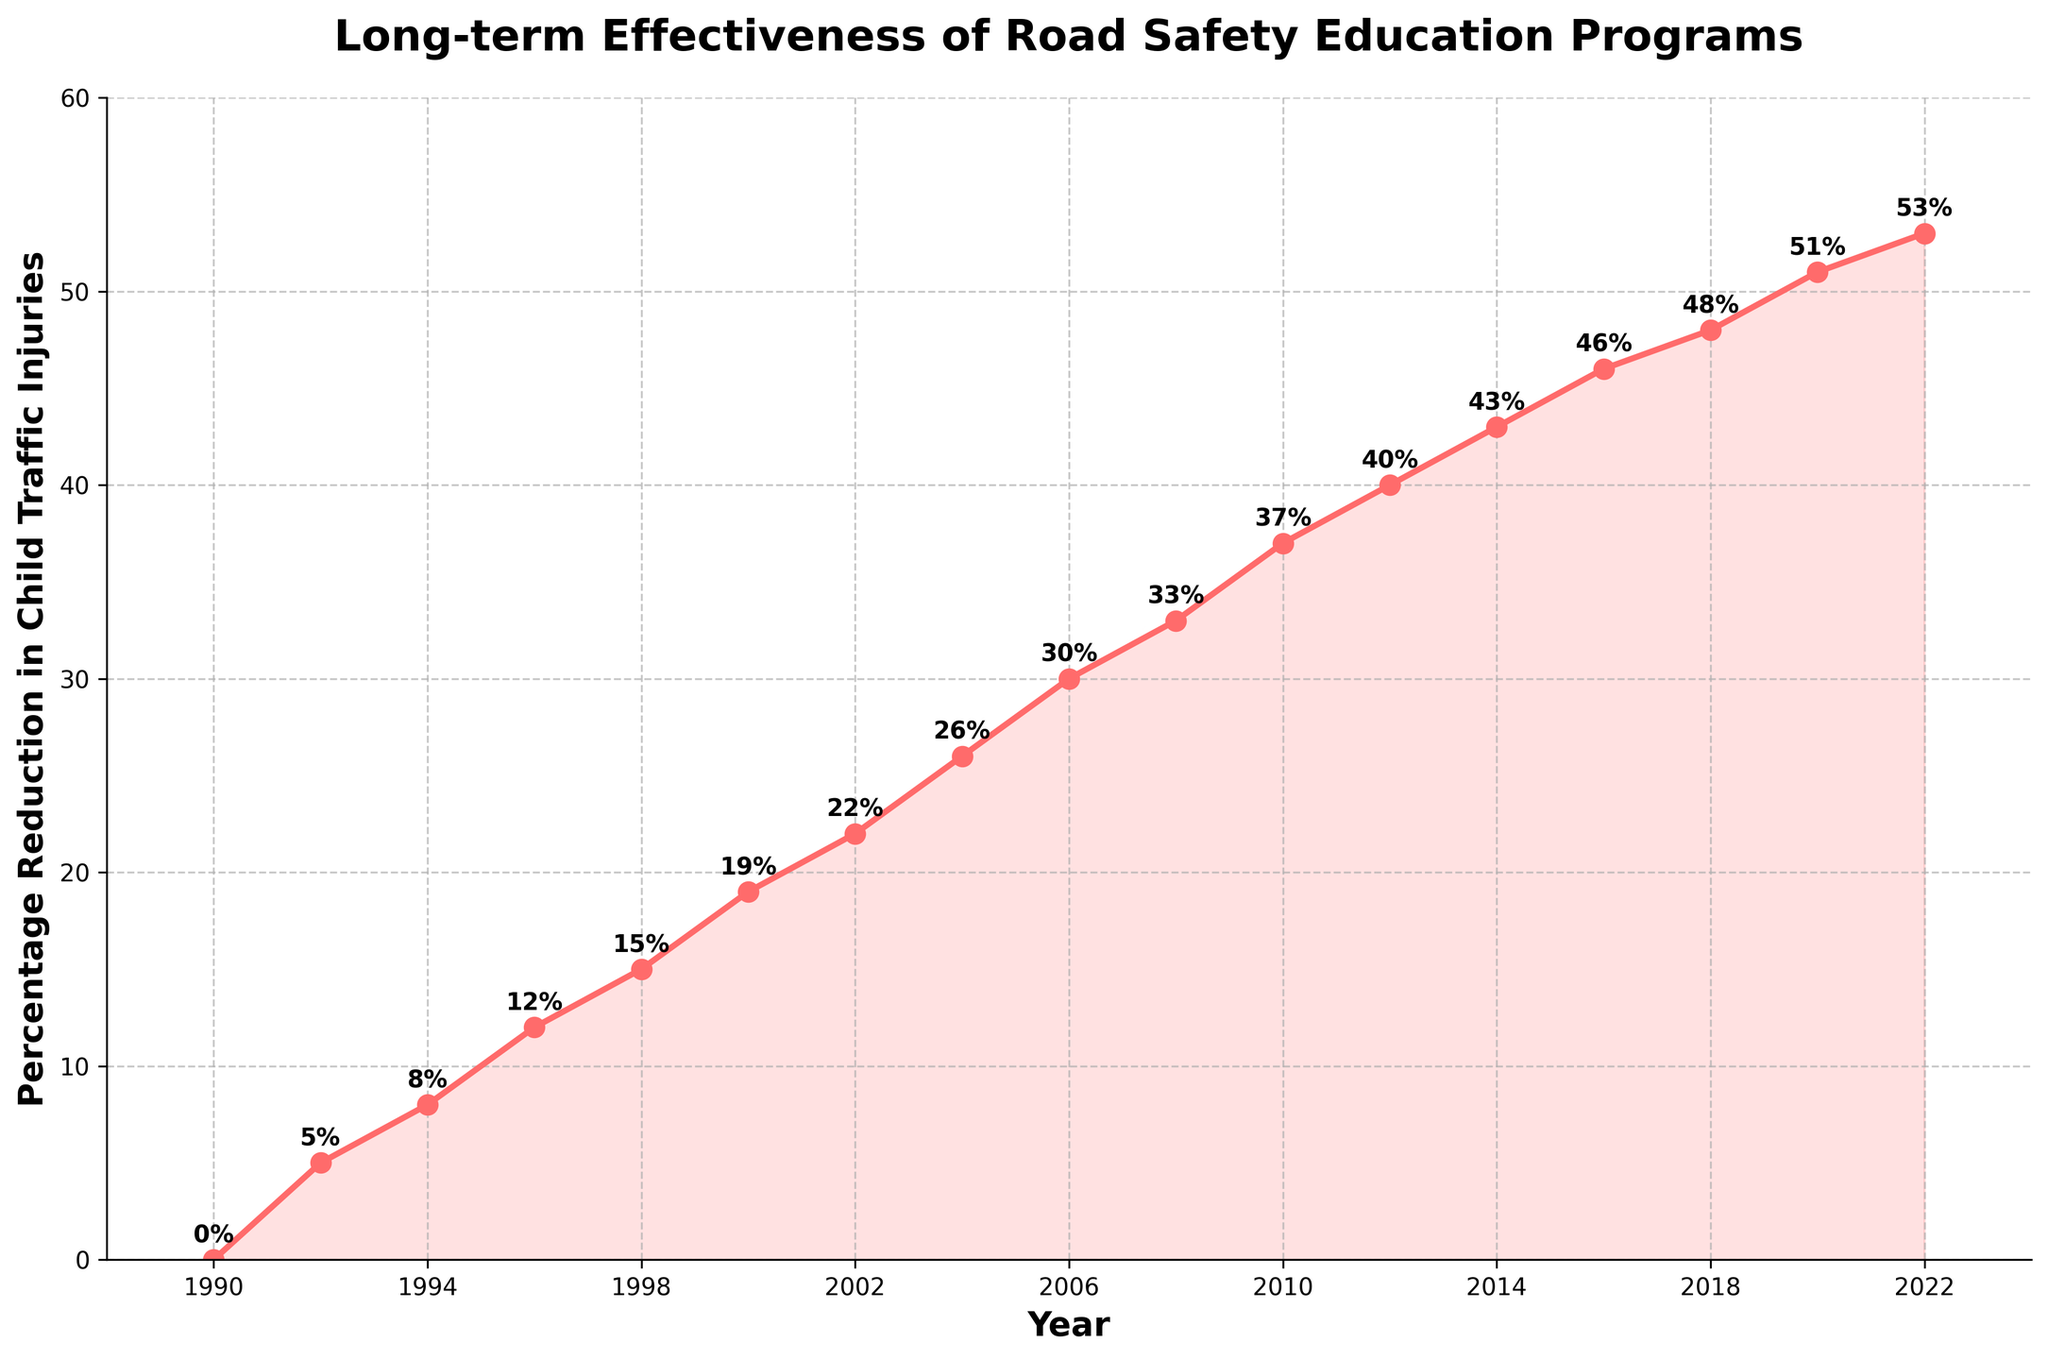What is the percentage reduction in child traffic injuries in the year 2010? Locate the data point on the line chart corresponding to the year 2010 and read the value displayed.
Answer: 37% By how much did the percentage reduction in child traffic injuries increase from 1990 to 2000? Find the values for the years 1990 and 2000 from the chart (0% in 1990 and 19% in 2000) and subtract the 1990 value from the 2000 value (19% - 0% = 19%).
Answer: 19% In which year did the percentage reduction in child traffic injuries reach 40%? Locate the point on the chart where the percentage reduction first reaches 40%. This corresponds to the year 2012.
Answer: 2012 How much greater was the percentage reduction in 2020 compared to 2018? Find the values for 2018 and 2020 from the chart (48% in 2018 and 51% in 2020). Subtract the 2018 value from the 2020 value (51% - 48% = 3%).
Answer: 3% What is the average percentage reduction in child traffic injuries over the period from 1990 to 2000? Identify the data points for 1990, 1992, 1994, 1996, 1998, and 2000 (0%, 5%, 8%, 12%, 15%, and 19%). Calculate the average by summing the values and dividing by six ((0 + 5 + 8 + 12 + 15 + 19) / 6 = 59 / 6 = 9.83%).
Answer: 9.83% Between which two years did the largest increase in percentage reduction occur, and what was the increase? Identify increases between each pair of consecutive data points. The largest increase is between 2008 (33%) and 2010 (37%), an increase of 4%.
Answer: 2008 and 2010, 4% Is there a year where the percentage reduction remained the same as in the previous year? Examine the trend in the line chart and determine if there is any year where the percentage reduction does not increase from the previous year. There is no such year; the reduction consistently increases.
Answer: No What is the median percentage reduction for the years provided in the chart? Arrange all the percentage reductions in ascending order and find the middle value or the average of the two middle values if the number of data points is even. Here, there are 17 data points, so the median is the 9th value (26% for 2004).
Answer: 26% Did the percentage reduction increase more between 1990-2000 or 2010-2020? Calculate the increase from 1990 to 2000 (19%) and from 2010 to 2020 (14%). Compare the two increases (19% > 14%).
Answer: 1990-2000 What is the difference in percentage reduction between the start and end points of the chart? Subtract the percentage reduction in 1990 (0%) from that in 2022 (53%) to get the difference (53% - 0% = 53%).
Answer: 53% 